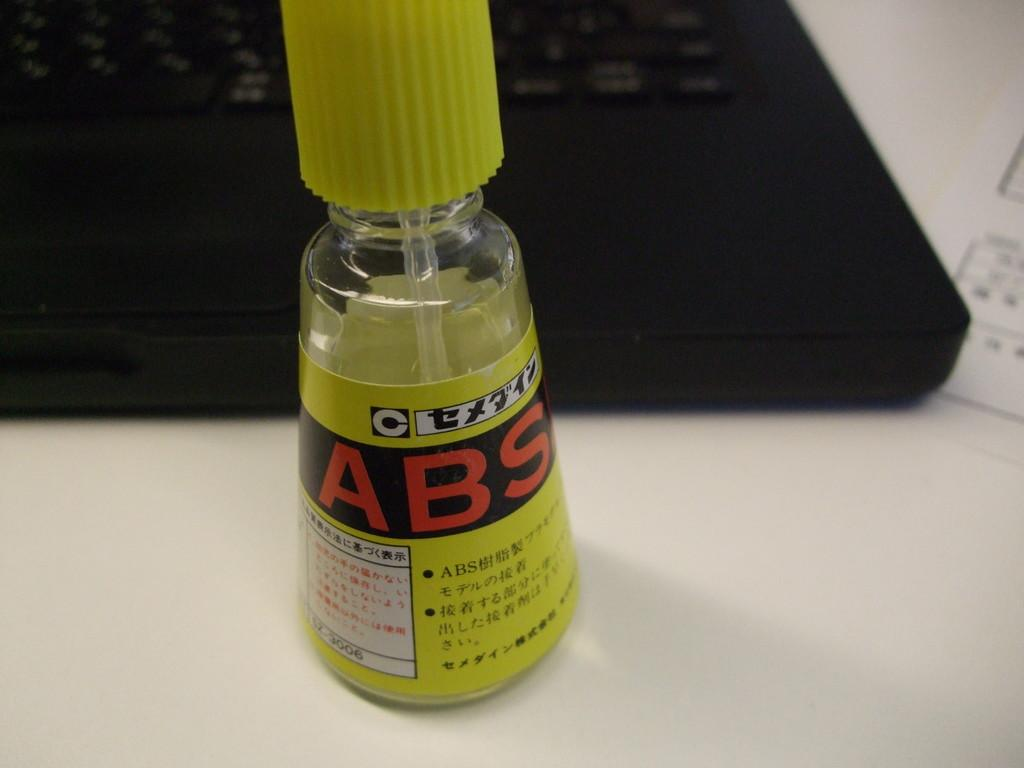<image>
Provide a brief description of the given image. A yellow bottle with a brush in it and the letters ABS visible on the side in red. 